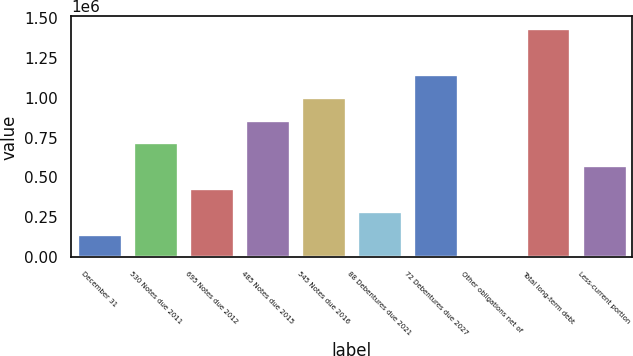<chart> <loc_0><loc_0><loc_500><loc_500><bar_chart><fcel>December 31<fcel>530 Notes due 2011<fcel>695 Notes due 2012<fcel>485 Notes due 2015<fcel>545 Notes due 2016<fcel>88 Debentures due 2021<fcel>72 Debentures due 2027<fcel>Other obligations net of<fcel>Total long-term debt<fcel>Less-current portion<nl><fcel>145449<fcel>719424<fcel>432436<fcel>862918<fcel>1.00641e+06<fcel>288943<fcel>1.14991e+06<fcel>1955<fcel>1.43689e+06<fcel>575930<nl></chart> 